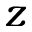Convert formula to latex. <formula><loc_0><loc_0><loc_500><loc_500>z</formula> 